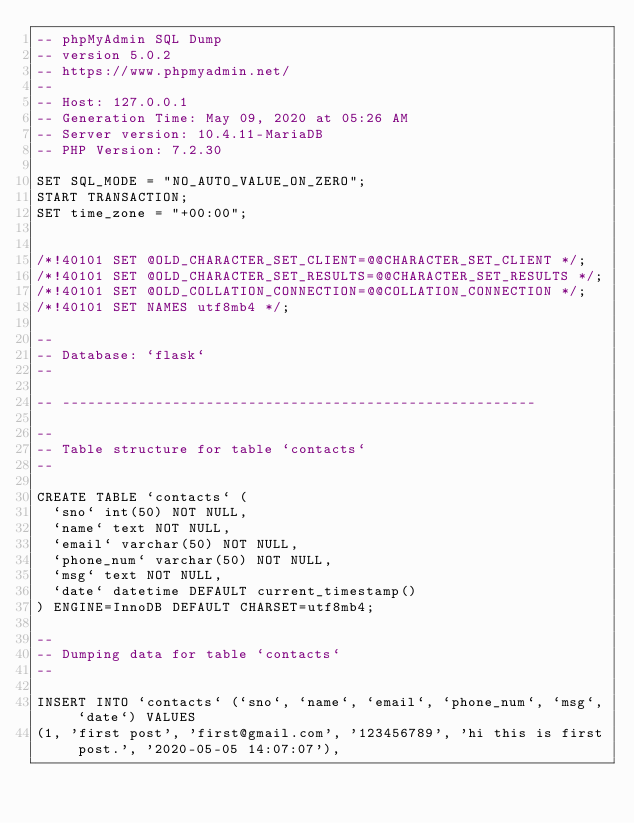Convert code to text. <code><loc_0><loc_0><loc_500><loc_500><_SQL_>-- phpMyAdmin SQL Dump
-- version 5.0.2
-- https://www.phpmyadmin.net/
--
-- Host: 127.0.0.1
-- Generation Time: May 09, 2020 at 05:26 AM
-- Server version: 10.4.11-MariaDB
-- PHP Version: 7.2.30

SET SQL_MODE = "NO_AUTO_VALUE_ON_ZERO";
START TRANSACTION;
SET time_zone = "+00:00";


/*!40101 SET @OLD_CHARACTER_SET_CLIENT=@@CHARACTER_SET_CLIENT */;
/*!40101 SET @OLD_CHARACTER_SET_RESULTS=@@CHARACTER_SET_RESULTS */;
/*!40101 SET @OLD_COLLATION_CONNECTION=@@COLLATION_CONNECTION */;
/*!40101 SET NAMES utf8mb4 */;

--
-- Database: `flask`
--

-- --------------------------------------------------------

--
-- Table structure for table `contacts`
--

CREATE TABLE `contacts` (
  `sno` int(50) NOT NULL,
  `name` text NOT NULL,
  `email` varchar(50) NOT NULL,
  `phone_num` varchar(50) NOT NULL,
  `msg` text NOT NULL,
  `date` datetime DEFAULT current_timestamp()
) ENGINE=InnoDB DEFAULT CHARSET=utf8mb4;

--
-- Dumping data for table `contacts`
--

INSERT INTO `contacts` (`sno`, `name`, `email`, `phone_num`, `msg`, `date`) VALUES
(1, 'first post', 'first@gmail.com', '123456789', 'hi this is first post.', '2020-05-05 14:07:07'),</code> 